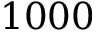<formula> <loc_0><loc_0><loc_500><loc_500>1 0 0 0</formula> 